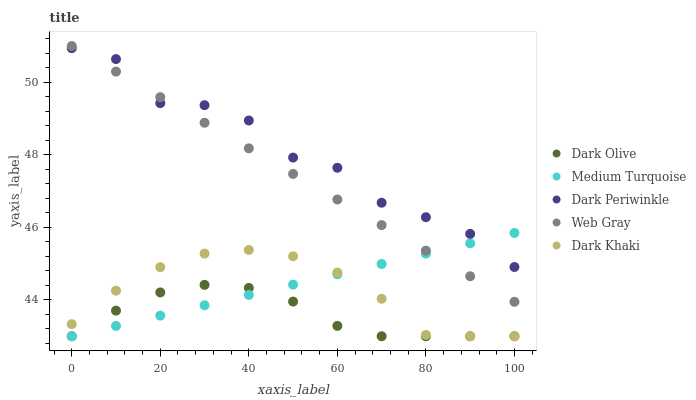Does Dark Olive have the minimum area under the curve?
Answer yes or no. Yes. Does Dark Periwinkle have the maximum area under the curve?
Answer yes or no. Yes. Does Web Gray have the minimum area under the curve?
Answer yes or no. No. Does Web Gray have the maximum area under the curve?
Answer yes or no. No. Is Web Gray the smoothest?
Answer yes or no. Yes. Is Dark Periwinkle the roughest?
Answer yes or no. Yes. Is Dark Olive the smoothest?
Answer yes or no. No. Is Dark Olive the roughest?
Answer yes or no. No. Does Dark Khaki have the lowest value?
Answer yes or no. Yes. Does Web Gray have the lowest value?
Answer yes or no. No. Does Web Gray have the highest value?
Answer yes or no. Yes. Does Dark Olive have the highest value?
Answer yes or no. No. Is Dark Olive less than Web Gray?
Answer yes or no. Yes. Is Web Gray greater than Dark Khaki?
Answer yes or no. Yes. Does Web Gray intersect Dark Periwinkle?
Answer yes or no. Yes. Is Web Gray less than Dark Periwinkle?
Answer yes or no. No. Is Web Gray greater than Dark Periwinkle?
Answer yes or no. No. Does Dark Olive intersect Web Gray?
Answer yes or no. No. 